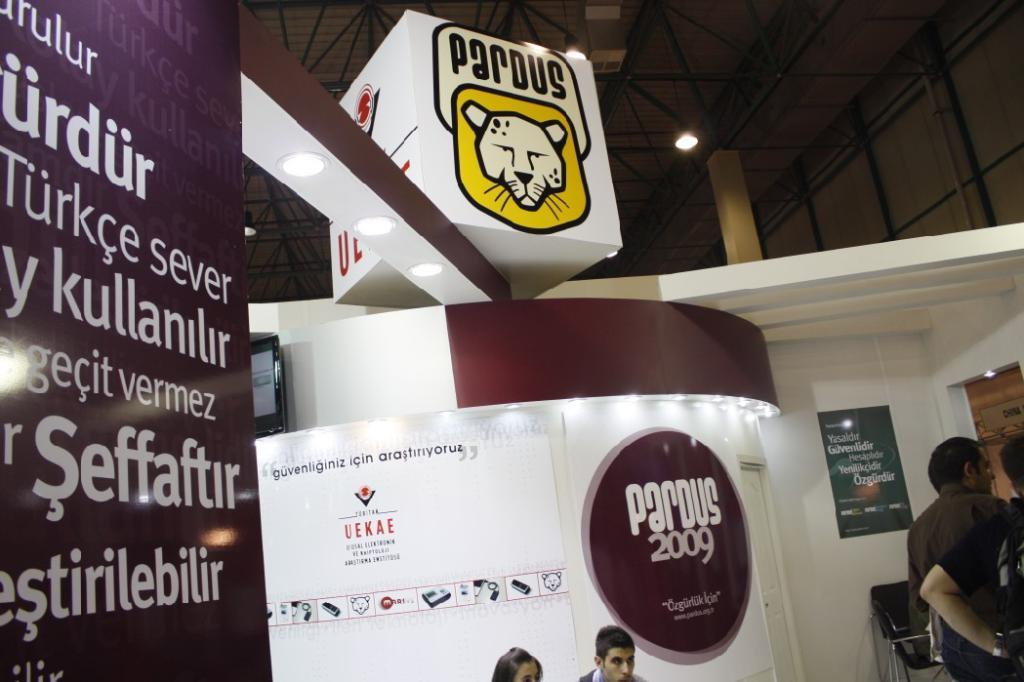Provide a one-sentence caption for the provided image. An event being held in a foreign city in the year 2009. 